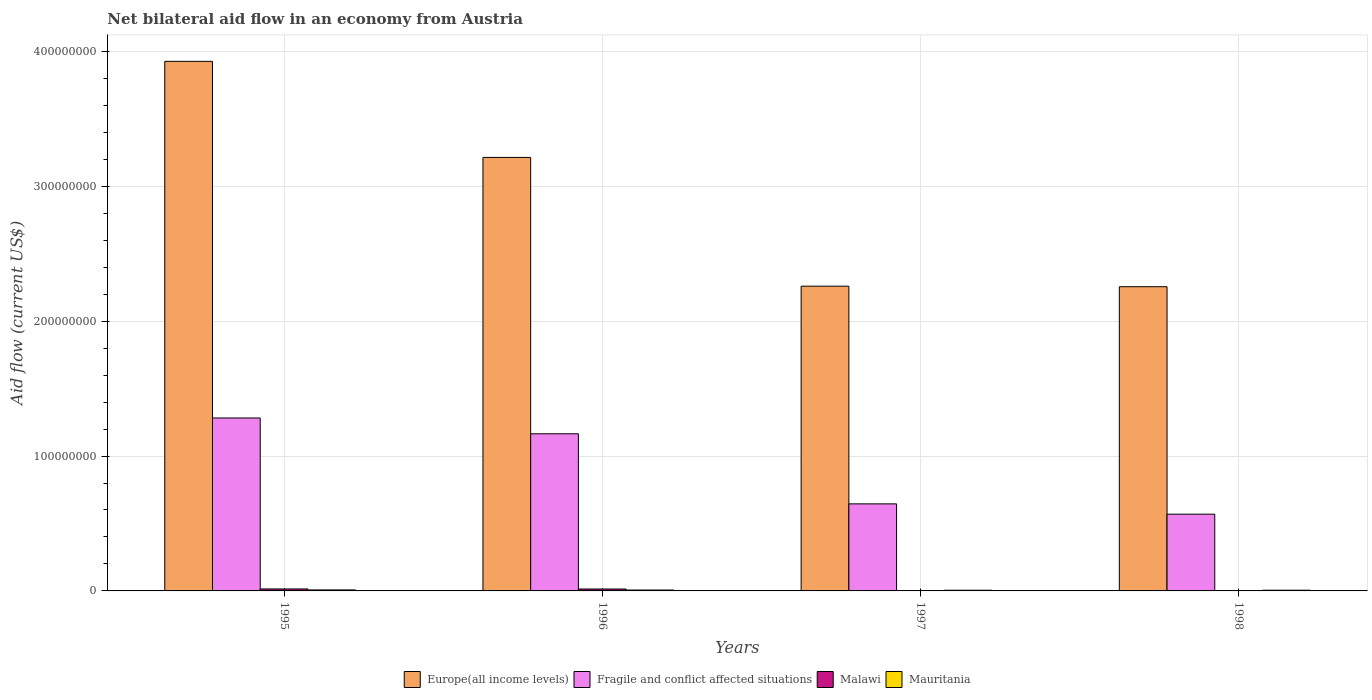How many groups of bars are there?
Your response must be concise. 4. Are the number of bars per tick equal to the number of legend labels?
Make the answer very short. Yes. Are the number of bars on each tick of the X-axis equal?
Your answer should be very brief. Yes. How many bars are there on the 4th tick from the left?
Your answer should be compact. 4. In how many cases, is the number of bars for a given year not equal to the number of legend labels?
Provide a succinct answer. 0. What is the net bilateral aid flow in Malawi in 1997?
Your response must be concise. 10000. Across all years, what is the maximum net bilateral aid flow in Mauritania?
Your response must be concise. 7.50e+05. Across all years, what is the minimum net bilateral aid flow in Europe(all income levels)?
Offer a very short reply. 2.26e+08. What is the total net bilateral aid flow in Malawi in the graph?
Your answer should be very brief. 2.97e+06. What is the difference between the net bilateral aid flow in Europe(all income levels) in 1998 and the net bilateral aid flow in Malawi in 1995?
Provide a short and direct response. 2.24e+08. What is the average net bilateral aid flow in Malawi per year?
Make the answer very short. 7.42e+05. In the year 1998, what is the difference between the net bilateral aid flow in Malawi and net bilateral aid flow in Mauritania?
Your answer should be compact. -4.50e+05. What is the ratio of the net bilateral aid flow in Fragile and conflict affected situations in 1995 to that in 1998?
Give a very brief answer. 2.25. What is the difference between the highest and the second highest net bilateral aid flow in Malawi?
Make the answer very short. 4.00e+04. What is the difference between the highest and the lowest net bilateral aid flow in Fragile and conflict affected situations?
Provide a succinct answer. 7.13e+07. What does the 2nd bar from the left in 1998 represents?
Offer a terse response. Fragile and conflict affected situations. What does the 1st bar from the right in 1997 represents?
Offer a very short reply. Mauritania. Is it the case that in every year, the sum of the net bilateral aid flow in Malawi and net bilateral aid flow in Mauritania is greater than the net bilateral aid flow in Europe(all income levels)?
Provide a succinct answer. No. How many bars are there?
Your answer should be very brief. 16. How many years are there in the graph?
Your answer should be very brief. 4. What is the difference between two consecutive major ticks on the Y-axis?
Your response must be concise. 1.00e+08. Does the graph contain any zero values?
Offer a very short reply. No. Does the graph contain grids?
Provide a succinct answer. Yes. How are the legend labels stacked?
Keep it short and to the point. Horizontal. What is the title of the graph?
Your answer should be very brief. Net bilateral aid flow in an economy from Austria. Does "Saudi Arabia" appear as one of the legend labels in the graph?
Your answer should be compact. No. What is the label or title of the Y-axis?
Offer a very short reply. Aid flow (current US$). What is the Aid flow (current US$) of Europe(all income levels) in 1995?
Provide a short and direct response. 3.93e+08. What is the Aid flow (current US$) of Fragile and conflict affected situations in 1995?
Your answer should be compact. 1.28e+08. What is the Aid flow (current US$) in Malawi in 1995?
Offer a terse response. 1.46e+06. What is the Aid flow (current US$) of Mauritania in 1995?
Your response must be concise. 7.50e+05. What is the Aid flow (current US$) of Europe(all income levels) in 1996?
Your answer should be compact. 3.21e+08. What is the Aid flow (current US$) in Fragile and conflict affected situations in 1996?
Keep it short and to the point. 1.16e+08. What is the Aid flow (current US$) in Malawi in 1996?
Ensure brevity in your answer.  1.42e+06. What is the Aid flow (current US$) in Mauritania in 1996?
Give a very brief answer. 6.60e+05. What is the Aid flow (current US$) of Europe(all income levels) in 1997?
Offer a terse response. 2.26e+08. What is the Aid flow (current US$) of Fragile and conflict affected situations in 1997?
Keep it short and to the point. 6.45e+07. What is the Aid flow (current US$) in Mauritania in 1997?
Make the answer very short. 5.10e+05. What is the Aid flow (current US$) in Europe(all income levels) in 1998?
Offer a terse response. 2.26e+08. What is the Aid flow (current US$) of Fragile and conflict affected situations in 1998?
Your answer should be very brief. 5.69e+07. What is the Aid flow (current US$) of Malawi in 1998?
Make the answer very short. 8.00e+04. What is the Aid flow (current US$) of Mauritania in 1998?
Make the answer very short. 5.30e+05. Across all years, what is the maximum Aid flow (current US$) in Europe(all income levels)?
Provide a succinct answer. 3.93e+08. Across all years, what is the maximum Aid flow (current US$) of Fragile and conflict affected situations?
Make the answer very short. 1.28e+08. Across all years, what is the maximum Aid flow (current US$) of Malawi?
Keep it short and to the point. 1.46e+06. Across all years, what is the maximum Aid flow (current US$) of Mauritania?
Ensure brevity in your answer.  7.50e+05. Across all years, what is the minimum Aid flow (current US$) in Europe(all income levels)?
Offer a terse response. 2.26e+08. Across all years, what is the minimum Aid flow (current US$) of Fragile and conflict affected situations?
Give a very brief answer. 5.69e+07. Across all years, what is the minimum Aid flow (current US$) of Mauritania?
Your response must be concise. 5.10e+05. What is the total Aid flow (current US$) in Europe(all income levels) in the graph?
Give a very brief answer. 1.17e+09. What is the total Aid flow (current US$) in Fragile and conflict affected situations in the graph?
Provide a short and direct response. 3.66e+08. What is the total Aid flow (current US$) of Malawi in the graph?
Your answer should be very brief. 2.97e+06. What is the total Aid flow (current US$) in Mauritania in the graph?
Make the answer very short. 2.45e+06. What is the difference between the Aid flow (current US$) in Europe(all income levels) in 1995 and that in 1996?
Keep it short and to the point. 7.12e+07. What is the difference between the Aid flow (current US$) in Fragile and conflict affected situations in 1995 and that in 1996?
Keep it short and to the point. 1.17e+07. What is the difference between the Aid flow (current US$) of Malawi in 1995 and that in 1996?
Provide a succinct answer. 4.00e+04. What is the difference between the Aid flow (current US$) in Mauritania in 1995 and that in 1996?
Provide a succinct answer. 9.00e+04. What is the difference between the Aid flow (current US$) in Europe(all income levels) in 1995 and that in 1997?
Your answer should be compact. 1.67e+08. What is the difference between the Aid flow (current US$) in Fragile and conflict affected situations in 1995 and that in 1997?
Your answer should be very brief. 6.37e+07. What is the difference between the Aid flow (current US$) in Malawi in 1995 and that in 1997?
Provide a succinct answer. 1.45e+06. What is the difference between the Aid flow (current US$) of Europe(all income levels) in 1995 and that in 1998?
Your answer should be very brief. 1.67e+08. What is the difference between the Aid flow (current US$) in Fragile and conflict affected situations in 1995 and that in 1998?
Your response must be concise. 7.13e+07. What is the difference between the Aid flow (current US$) of Malawi in 1995 and that in 1998?
Give a very brief answer. 1.38e+06. What is the difference between the Aid flow (current US$) of Mauritania in 1995 and that in 1998?
Offer a terse response. 2.20e+05. What is the difference between the Aid flow (current US$) of Europe(all income levels) in 1996 and that in 1997?
Your answer should be very brief. 9.54e+07. What is the difference between the Aid flow (current US$) in Fragile and conflict affected situations in 1996 and that in 1997?
Offer a terse response. 5.20e+07. What is the difference between the Aid flow (current US$) of Malawi in 1996 and that in 1997?
Offer a terse response. 1.41e+06. What is the difference between the Aid flow (current US$) in Mauritania in 1996 and that in 1997?
Ensure brevity in your answer.  1.50e+05. What is the difference between the Aid flow (current US$) of Europe(all income levels) in 1996 and that in 1998?
Offer a very short reply. 9.58e+07. What is the difference between the Aid flow (current US$) of Fragile and conflict affected situations in 1996 and that in 1998?
Provide a succinct answer. 5.96e+07. What is the difference between the Aid flow (current US$) in Malawi in 1996 and that in 1998?
Offer a very short reply. 1.34e+06. What is the difference between the Aid flow (current US$) of Europe(all income levels) in 1997 and that in 1998?
Provide a succinct answer. 4.00e+05. What is the difference between the Aid flow (current US$) of Fragile and conflict affected situations in 1997 and that in 1998?
Ensure brevity in your answer.  7.65e+06. What is the difference between the Aid flow (current US$) of Malawi in 1997 and that in 1998?
Give a very brief answer. -7.00e+04. What is the difference between the Aid flow (current US$) of Mauritania in 1997 and that in 1998?
Your answer should be very brief. -2.00e+04. What is the difference between the Aid flow (current US$) of Europe(all income levels) in 1995 and the Aid flow (current US$) of Fragile and conflict affected situations in 1996?
Make the answer very short. 2.76e+08. What is the difference between the Aid flow (current US$) in Europe(all income levels) in 1995 and the Aid flow (current US$) in Malawi in 1996?
Give a very brief answer. 3.91e+08. What is the difference between the Aid flow (current US$) in Europe(all income levels) in 1995 and the Aid flow (current US$) in Mauritania in 1996?
Keep it short and to the point. 3.92e+08. What is the difference between the Aid flow (current US$) in Fragile and conflict affected situations in 1995 and the Aid flow (current US$) in Malawi in 1996?
Keep it short and to the point. 1.27e+08. What is the difference between the Aid flow (current US$) in Fragile and conflict affected situations in 1995 and the Aid flow (current US$) in Mauritania in 1996?
Offer a very short reply. 1.28e+08. What is the difference between the Aid flow (current US$) in Europe(all income levels) in 1995 and the Aid flow (current US$) in Fragile and conflict affected situations in 1997?
Ensure brevity in your answer.  3.28e+08. What is the difference between the Aid flow (current US$) of Europe(all income levels) in 1995 and the Aid flow (current US$) of Malawi in 1997?
Offer a terse response. 3.93e+08. What is the difference between the Aid flow (current US$) in Europe(all income levels) in 1995 and the Aid flow (current US$) in Mauritania in 1997?
Offer a very short reply. 3.92e+08. What is the difference between the Aid flow (current US$) in Fragile and conflict affected situations in 1995 and the Aid flow (current US$) in Malawi in 1997?
Ensure brevity in your answer.  1.28e+08. What is the difference between the Aid flow (current US$) of Fragile and conflict affected situations in 1995 and the Aid flow (current US$) of Mauritania in 1997?
Ensure brevity in your answer.  1.28e+08. What is the difference between the Aid flow (current US$) in Malawi in 1995 and the Aid flow (current US$) in Mauritania in 1997?
Your answer should be very brief. 9.50e+05. What is the difference between the Aid flow (current US$) of Europe(all income levels) in 1995 and the Aid flow (current US$) of Fragile and conflict affected situations in 1998?
Keep it short and to the point. 3.36e+08. What is the difference between the Aid flow (current US$) of Europe(all income levels) in 1995 and the Aid flow (current US$) of Malawi in 1998?
Provide a short and direct response. 3.92e+08. What is the difference between the Aid flow (current US$) in Europe(all income levels) in 1995 and the Aid flow (current US$) in Mauritania in 1998?
Offer a very short reply. 3.92e+08. What is the difference between the Aid flow (current US$) of Fragile and conflict affected situations in 1995 and the Aid flow (current US$) of Malawi in 1998?
Your answer should be compact. 1.28e+08. What is the difference between the Aid flow (current US$) of Fragile and conflict affected situations in 1995 and the Aid flow (current US$) of Mauritania in 1998?
Offer a very short reply. 1.28e+08. What is the difference between the Aid flow (current US$) in Malawi in 1995 and the Aid flow (current US$) in Mauritania in 1998?
Offer a terse response. 9.30e+05. What is the difference between the Aid flow (current US$) of Europe(all income levels) in 1996 and the Aid flow (current US$) of Fragile and conflict affected situations in 1997?
Offer a terse response. 2.57e+08. What is the difference between the Aid flow (current US$) of Europe(all income levels) in 1996 and the Aid flow (current US$) of Malawi in 1997?
Ensure brevity in your answer.  3.21e+08. What is the difference between the Aid flow (current US$) in Europe(all income levels) in 1996 and the Aid flow (current US$) in Mauritania in 1997?
Your response must be concise. 3.21e+08. What is the difference between the Aid flow (current US$) of Fragile and conflict affected situations in 1996 and the Aid flow (current US$) of Malawi in 1997?
Provide a short and direct response. 1.16e+08. What is the difference between the Aid flow (current US$) of Fragile and conflict affected situations in 1996 and the Aid flow (current US$) of Mauritania in 1997?
Your answer should be very brief. 1.16e+08. What is the difference between the Aid flow (current US$) in Malawi in 1996 and the Aid flow (current US$) in Mauritania in 1997?
Offer a very short reply. 9.10e+05. What is the difference between the Aid flow (current US$) in Europe(all income levels) in 1996 and the Aid flow (current US$) in Fragile and conflict affected situations in 1998?
Make the answer very short. 2.64e+08. What is the difference between the Aid flow (current US$) in Europe(all income levels) in 1996 and the Aid flow (current US$) in Malawi in 1998?
Your response must be concise. 3.21e+08. What is the difference between the Aid flow (current US$) in Europe(all income levels) in 1996 and the Aid flow (current US$) in Mauritania in 1998?
Provide a short and direct response. 3.21e+08. What is the difference between the Aid flow (current US$) of Fragile and conflict affected situations in 1996 and the Aid flow (current US$) of Malawi in 1998?
Your answer should be very brief. 1.16e+08. What is the difference between the Aid flow (current US$) of Fragile and conflict affected situations in 1996 and the Aid flow (current US$) of Mauritania in 1998?
Keep it short and to the point. 1.16e+08. What is the difference between the Aid flow (current US$) of Malawi in 1996 and the Aid flow (current US$) of Mauritania in 1998?
Ensure brevity in your answer.  8.90e+05. What is the difference between the Aid flow (current US$) of Europe(all income levels) in 1997 and the Aid flow (current US$) of Fragile and conflict affected situations in 1998?
Provide a succinct answer. 1.69e+08. What is the difference between the Aid flow (current US$) in Europe(all income levels) in 1997 and the Aid flow (current US$) in Malawi in 1998?
Keep it short and to the point. 2.26e+08. What is the difference between the Aid flow (current US$) of Europe(all income levels) in 1997 and the Aid flow (current US$) of Mauritania in 1998?
Offer a very short reply. 2.25e+08. What is the difference between the Aid flow (current US$) of Fragile and conflict affected situations in 1997 and the Aid flow (current US$) of Malawi in 1998?
Your answer should be compact. 6.45e+07. What is the difference between the Aid flow (current US$) in Fragile and conflict affected situations in 1997 and the Aid flow (current US$) in Mauritania in 1998?
Give a very brief answer. 6.40e+07. What is the difference between the Aid flow (current US$) of Malawi in 1997 and the Aid flow (current US$) of Mauritania in 1998?
Your answer should be very brief. -5.20e+05. What is the average Aid flow (current US$) in Europe(all income levels) per year?
Make the answer very short. 2.91e+08. What is the average Aid flow (current US$) of Fragile and conflict affected situations per year?
Give a very brief answer. 9.15e+07. What is the average Aid flow (current US$) in Malawi per year?
Offer a very short reply. 7.42e+05. What is the average Aid flow (current US$) of Mauritania per year?
Ensure brevity in your answer.  6.12e+05. In the year 1995, what is the difference between the Aid flow (current US$) of Europe(all income levels) and Aid flow (current US$) of Fragile and conflict affected situations?
Provide a short and direct response. 2.64e+08. In the year 1995, what is the difference between the Aid flow (current US$) of Europe(all income levels) and Aid flow (current US$) of Malawi?
Ensure brevity in your answer.  3.91e+08. In the year 1995, what is the difference between the Aid flow (current US$) of Europe(all income levels) and Aid flow (current US$) of Mauritania?
Offer a terse response. 3.92e+08. In the year 1995, what is the difference between the Aid flow (current US$) of Fragile and conflict affected situations and Aid flow (current US$) of Malawi?
Make the answer very short. 1.27e+08. In the year 1995, what is the difference between the Aid flow (current US$) in Fragile and conflict affected situations and Aid flow (current US$) in Mauritania?
Your answer should be compact. 1.27e+08. In the year 1995, what is the difference between the Aid flow (current US$) in Malawi and Aid flow (current US$) in Mauritania?
Your answer should be very brief. 7.10e+05. In the year 1996, what is the difference between the Aid flow (current US$) of Europe(all income levels) and Aid flow (current US$) of Fragile and conflict affected situations?
Keep it short and to the point. 2.05e+08. In the year 1996, what is the difference between the Aid flow (current US$) in Europe(all income levels) and Aid flow (current US$) in Malawi?
Offer a terse response. 3.20e+08. In the year 1996, what is the difference between the Aid flow (current US$) of Europe(all income levels) and Aid flow (current US$) of Mauritania?
Your response must be concise. 3.21e+08. In the year 1996, what is the difference between the Aid flow (current US$) of Fragile and conflict affected situations and Aid flow (current US$) of Malawi?
Give a very brief answer. 1.15e+08. In the year 1996, what is the difference between the Aid flow (current US$) of Fragile and conflict affected situations and Aid flow (current US$) of Mauritania?
Give a very brief answer. 1.16e+08. In the year 1996, what is the difference between the Aid flow (current US$) of Malawi and Aid flow (current US$) of Mauritania?
Make the answer very short. 7.60e+05. In the year 1997, what is the difference between the Aid flow (current US$) in Europe(all income levels) and Aid flow (current US$) in Fragile and conflict affected situations?
Offer a very short reply. 1.61e+08. In the year 1997, what is the difference between the Aid flow (current US$) of Europe(all income levels) and Aid flow (current US$) of Malawi?
Offer a terse response. 2.26e+08. In the year 1997, what is the difference between the Aid flow (current US$) in Europe(all income levels) and Aid flow (current US$) in Mauritania?
Offer a very short reply. 2.25e+08. In the year 1997, what is the difference between the Aid flow (current US$) of Fragile and conflict affected situations and Aid flow (current US$) of Malawi?
Ensure brevity in your answer.  6.45e+07. In the year 1997, what is the difference between the Aid flow (current US$) of Fragile and conflict affected situations and Aid flow (current US$) of Mauritania?
Offer a terse response. 6.40e+07. In the year 1997, what is the difference between the Aid flow (current US$) in Malawi and Aid flow (current US$) in Mauritania?
Your answer should be compact. -5.00e+05. In the year 1998, what is the difference between the Aid flow (current US$) of Europe(all income levels) and Aid flow (current US$) of Fragile and conflict affected situations?
Give a very brief answer. 1.69e+08. In the year 1998, what is the difference between the Aid flow (current US$) in Europe(all income levels) and Aid flow (current US$) in Malawi?
Provide a succinct answer. 2.25e+08. In the year 1998, what is the difference between the Aid flow (current US$) in Europe(all income levels) and Aid flow (current US$) in Mauritania?
Your answer should be compact. 2.25e+08. In the year 1998, what is the difference between the Aid flow (current US$) in Fragile and conflict affected situations and Aid flow (current US$) in Malawi?
Offer a terse response. 5.68e+07. In the year 1998, what is the difference between the Aid flow (current US$) of Fragile and conflict affected situations and Aid flow (current US$) of Mauritania?
Offer a very short reply. 5.64e+07. In the year 1998, what is the difference between the Aid flow (current US$) in Malawi and Aid flow (current US$) in Mauritania?
Provide a succinct answer. -4.50e+05. What is the ratio of the Aid flow (current US$) in Europe(all income levels) in 1995 to that in 1996?
Make the answer very short. 1.22. What is the ratio of the Aid flow (current US$) of Fragile and conflict affected situations in 1995 to that in 1996?
Keep it short and to the point. 1.1. What is the ratio of the Aid flow (current US$) of Malawi in 1995 to that in 1996?
Keep it short and to the point. 1.03. What is the ratio of the Aid flow (current US$) of Mauritania in 1995 to that in 1996?
Your answer should be very brief. 1.14. What is the ratio of the Aid flow (current US$) of Europe(all income levels) in 1995 to that in 1997?
Provide a succinct answer. 1.74. What is the ratio of the Aid flow (current US$) in Fragile and conflict affected situations in 1995 to that in 1997?
Provide a short and direct response. 1.99. What is the ratio of the Aid flow (current US$) in Malawi in 1995 to that in 1997?
Offer a very short reply. 146. What is the ratio of the Aid flow (current US$) of Mauritania in 1995 to that in 1997?
Offer a very short reply. 1.47. What is the ratio of the Aid flow (current US$) of Europe(all income levels) in 1995 to that in 1998?
Provide a succinct answer. 1.74. What is the ratio of the Aid flow (current US$) of Fragile and conflict affected situations in 1995 to that in 1998?
Your answer should be very brief. 2.25. What is the ratio of the Aid flow (current US$) in Malawi in 1995 to that in 1998?
Ensure brevity in your answer.  18.25. What is the ratio of the Aid flow (current US$) in Mauritania in 1995 to that in 1998?
Ensure brevity in your answer.  1.42. What is the ratio of the Aid flow (current US$) in Europe(all income levels) in 1996 to that in 1997?
Your response must be concise. 1.42. What is the ratio of the Aid flow (current US$) of Fragile and conflict affected situations in 1996 to that in 1997?
Your answer should be compact. 1.8. What is the ratio of the Aid flow (current US$) in Malawi in 1996 to that in 1997?
Ensure brevity in your answer.  142. What is the ratio of the Aid flow (current US$) of Mauritania in 1996 to that in 1997?
Keep it short and to the point. 1.29. What is the ratio of the Aid flow (current US$) in Europe(all income levels) in 1996 to that in 1998?
Provide a short and direct response. 1.43. What is the ratio of the Aid flow (current US$) in Fragile and conflict affected situations in 1996 to that in 1998?
Ensure brevity in your answer.  2.05. What is the ratio of the Aid flow (current US$) in Malawi in 1996 to that in 1998?
Provide a short and direct response. 17.75. What is the ratio of the Aid flow (current US$) of Mauritania in 1996 to that in 1998?
Offer a terse response. 1.25. What is the ratio of the Aid flow (current US$) in Fragile and conflict affected situations in 1997 to that in 1998?
Offer a terse response. 1.13. What is the ratio of the Aid flow (current US$) in Mauritania in 1997 to that in 1998?
Give a very brief answer. 0.96. What is the difference between the highest and the second highest Aid flow (current US$) of Europe(all income levels)?
Make the answer very short. 7.12e+07. What is the difference between the highest and the second highest Aid flow (current US$) of Fragile and conflict affected situations?
Your answer should be very brief. 1.17e+07. What is the difference between the highest and the second highest Aid flow (current US$) of Mauritania?
Offer a terse response. 9.00e+04. What is the difference between the highest and the lowest Aid flow (current US$) of Europe(all income levels)?
Provide a succinct answer. 1.67e+08. What is the difference between the highest and the lowest Aid flow (current US$) in Fragile and conflict affected situations?
Keep it short and to the point. 7.13e+07. What is the difference between the highest and the lowest Aid flow (current US$) in Malawi?
Make the answer very short. 1.45e+06. 